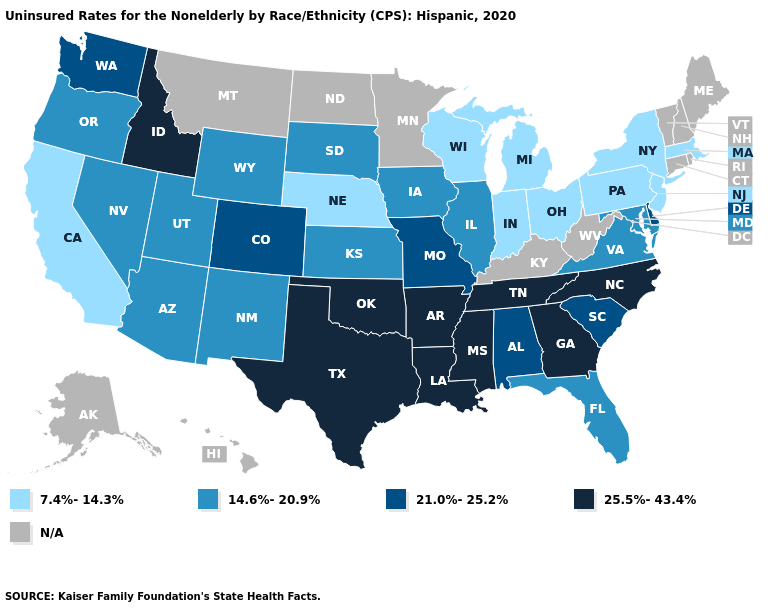What is the highest value in the Northeast ?
Give a very brief answer. 7.4%-14.3%. Is the legend a continuous bar?
Concise answer only. No. What is the value of Tennessee?
Give a very brief answer. 25.5%-43.4%. How many symbols are there in the legend?
Be succinct. 5. Name the states that have a value in the range 25.5%-43.4%?
Quick response, please. Arkansas, Georgia, Idaho, Louisiana, Mississippi, North Carolina, Oklahoma, Tennessee, Texas. What is the value of New Hampshire?
Answer briefly. N/A. Among the states that border Kentucky , which have the highest value?
Quick response, please. Tennessee. Name the states that have a value in the range 21.0%-25.2%?
Short answer required. Alabama, Colorado, Delaware, Missouri, South Carolina, Washington. How many symbols are there in the legend?
Keep it brief. 5. What is the lowest value in the West?
Write a very short answer. 7.4%-14.3%. Does the first symbol in the legend represent the smallest category?
Quick response, please. Yes. Does Georgia have the highest value in the USA?
Be succinct. Yes. What is the highest value in the West ?
Keep it brief. 25.5%-43.4%. What is the value of North Dakota?
Give a very brief answer. N/A. 